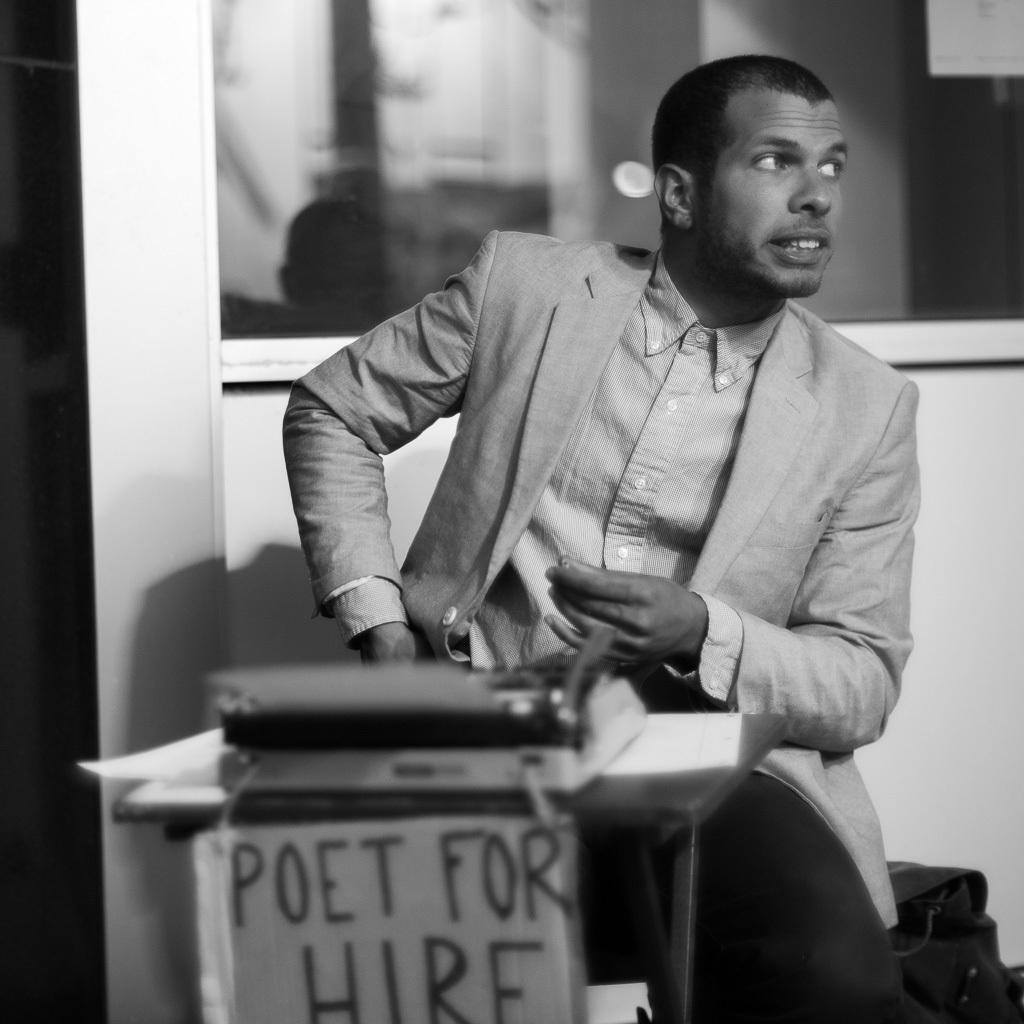What is the man in the image doing? The man is sitting in the image. What is the man wearing? The man is wearing a coat. What is present on the table in the image? There is a book on the table. What can be seen in the background of the image? There is a wall and a window in the background of the image. What type of transport is visible in the image? There is no transport visible in the image. What is the reason for the man sitting in the image? The image does not provide information about the man's reason for sitting, so we cannot determine the reason from the image. 